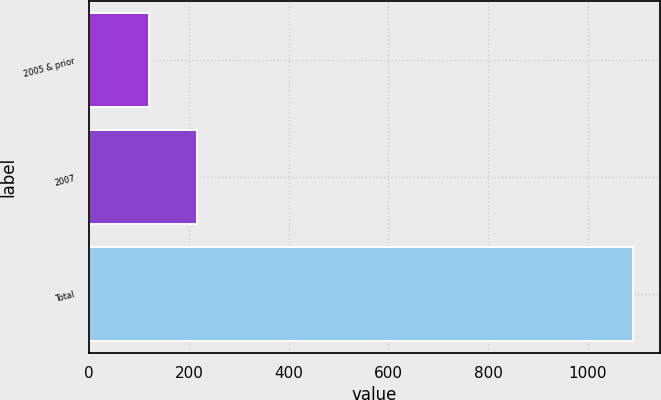Convert chart. <chart><loc_0><loc_0><loc_500><loc_500><bar_chart><fcel>2005 & prior<fcel>2007<fcel>Total<nl><fcel>120<fcel>217<fcel>1090<nl></chart> 